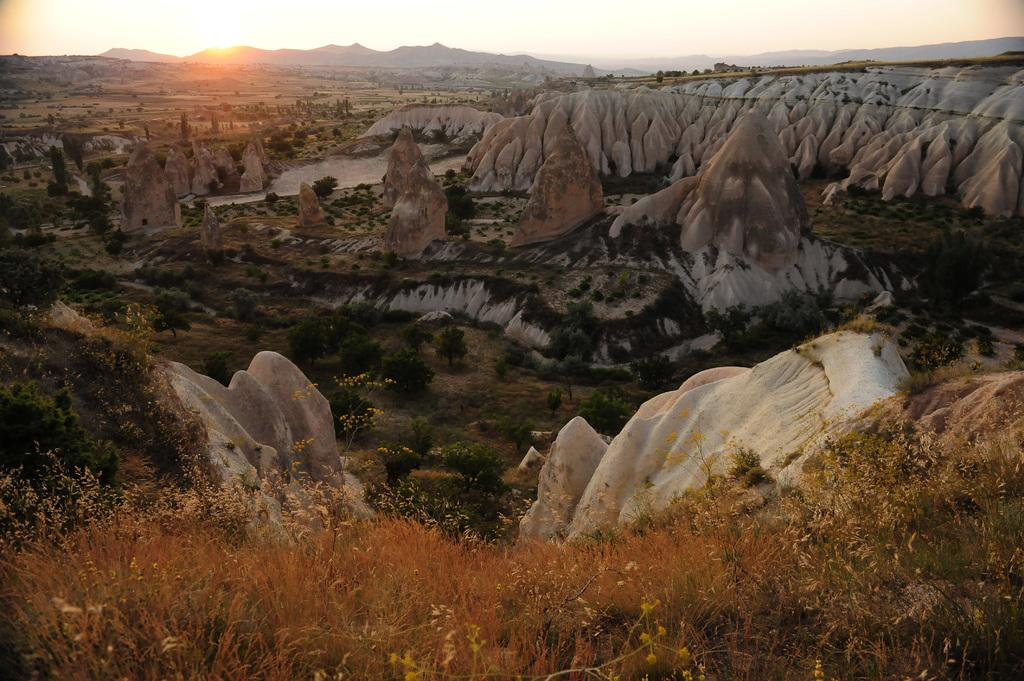What type of natural landscape is depicted in the image? There are mountains in the image. What other elements can be seen in the image besides the mountains? Trees and plants are present in the image. What is the condition of the sky in the image? The sun is visible in the sky. What type of job does the father have in the image? There is no father present in the image, as it depicts a natural landscape with mountains, trees, plants, and the sun. 